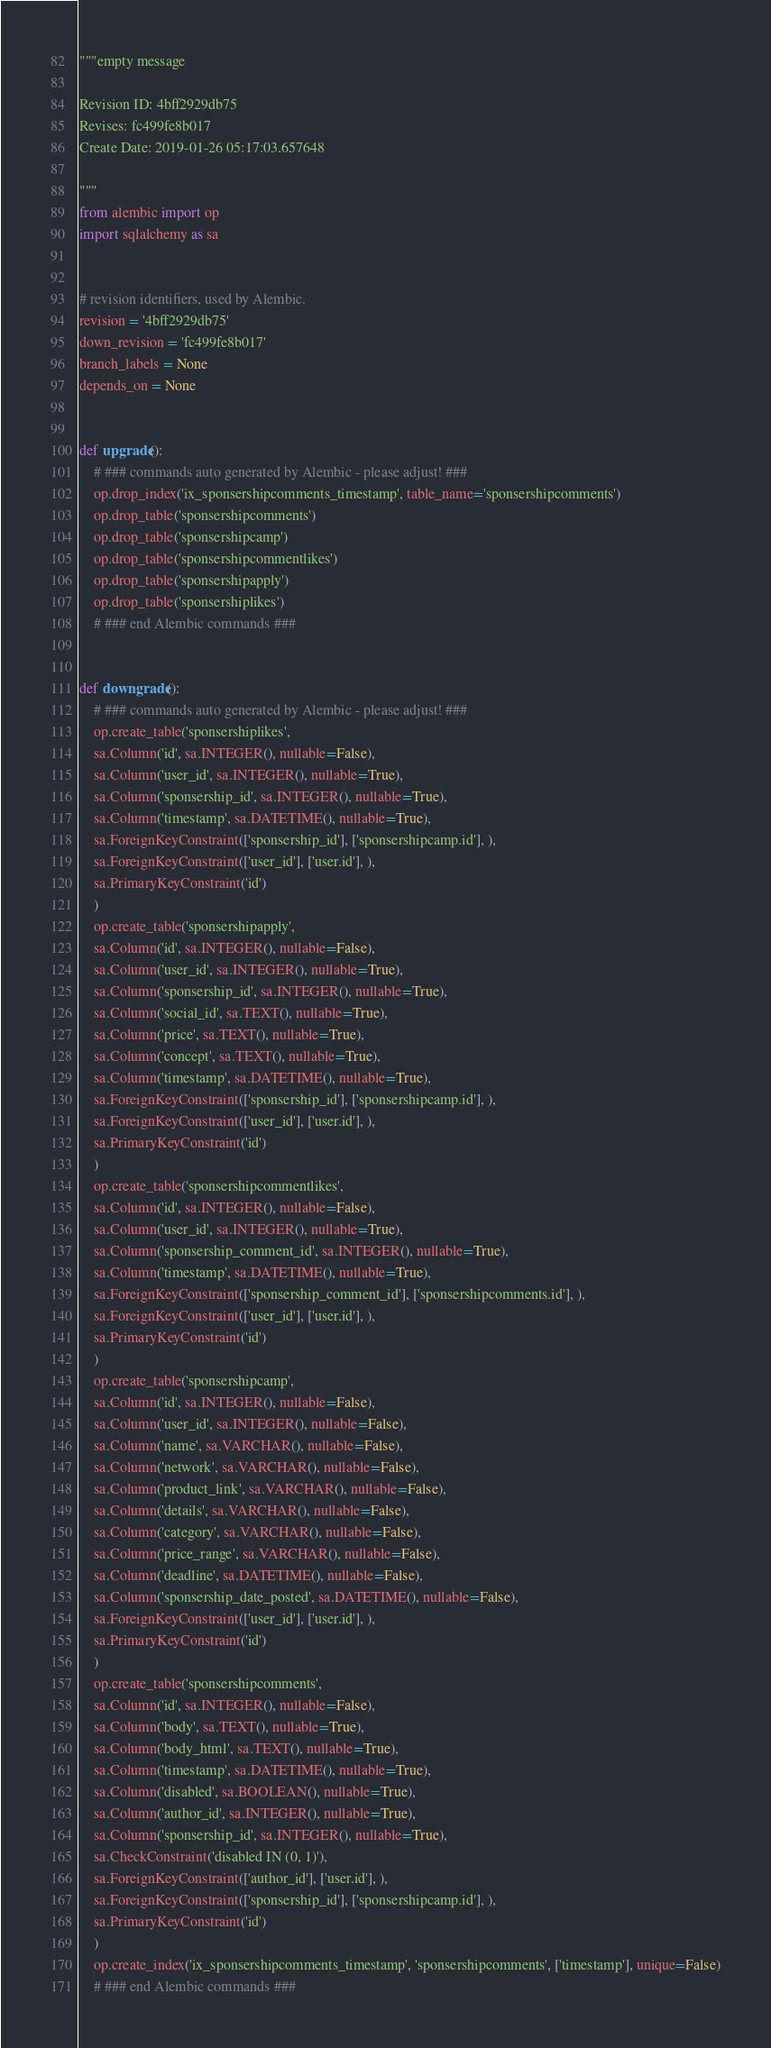Convert code to text. <code><loc_0><loc_0><loc_500><loc_500><_Python_>"""empty message

Revision ID: 4bff2929db75
Revises: fc499fe8b017
Create Date: 2019-01-26 05:17:03.657648

"""
from alembic import op
import sqlalchemy as sa


# revision identifiers, used by Alembic.
revision = '4bff2929db75'
down_revision = 'fc499fe8b017'
branch_labels = None
depends_on = None


def upgrade():
    # ### commands auto generated by Alembic - please adjust! ###
    op.drop_index('ix_sponsershipcomments_timestamp', table_name='sponsershipcomments')
    op.drop_table('sponsershipcomments')
    op.drop_table('sponsershipcamp')
    op.drop_table('sponsershipcommentlikes')
    op.drop_table('sponsershipapply')
    op.drop_table('sponsershiplikes')
    # ### end Alembic commands ###


def downgrade():
    # ### commands auto generated by Alembic - please adjust! ###
    op.create_table('sponsershiplikes',
    sa.Column('id', sa.INTEGER(), nullable=False),
    sa.Column('user_id', sa.INTEGER(), nullable=True),
    sa.Column('sponsership_id', sa.INTEGER(), nullable=True),
    sa.Column('timestamp', sa.DATETIME(), nullable=True),
    sa.ForeignKeyConstraint(['sponsership_id'], ['sponsershipcamp.id'], ),
    sa.ForeignKeyConstraint(['user_id'], ['user.id'], ),
    sa.PrimaryKeyConstraint('id')
    )
    op.create_table('sponsershipapply',
    sa.Column('id', sa.INTEGER(), nullable=False),
    sa.Column('user_id', sa.INTEGER(), nullable=True),
    sa.Column('sponsership_id', sa.INTEGER(), nullable=True),
    sa.Column('social_id', sa.TEXT(), nullable=True),
    sa.Column('price', sa.TEXT(), nullable=True),
    sa.Column('concept', sa.TEXT(), nullable=True),
    sa.Column('timestamp', sa.DATETIME(), nullable=True),
    sa.ForeignKeyConstraint(['sponsership_id'], ['sponsershipcamp.id'], ),
    sa.ForeignKeyConstraint(['user_id'], ['user.id'], ),
    sa.PrimaryKeyConstraint('id')
    )
    op.create_table('sponsershipcommentlikes',
    sa.Column('id', sa.INTEGER(), nullable=False),
    sa.Column('user_id', sa.INTEGER(), nullable=True),
    sa.Column('sponsership_comment_id', sa.INTEGER(), nullable=True),
    sa.Column('timestamp', sa.DATETIME(), nullable=True),
    sa.ForeignKeyConstraint(['sponsership_comment_id'], ['sponsershipcomments.id'], ),
    sa.ForeignKeyConstraint(['user_id'], ['user.id'], ),
    sa.PrimaryKeyConstraint('id')
    )
    op.create_table('sponsershipcamp',
    sa.Column('id', sa.INTEGER(), nullable=False),
    sa.Column('user_id', sa.INTEGER(), nullable=False),
    sa.Column('name', sa.VARCHAR(), nullable=False),
    sa.Column('network', sa.VARCHAR(), nullable=False),
    sa.Column('product_link', sa.VARCHAR(), nullable=False),
    sa.Column('details', sa.VARCHAR(), nullable=False),
    sa.Column('category', sa.VARCHAR(), nullable=False),
    sa.Column('price_range', sa.VARCHAR(), nullable=False),
    sa.Column('deadline', sa.DATETIME(), nullable=False),
    sa.Column('sponsership_date_posted', sa.DATETIME(), nullable=False),
    sa.ForeignKeyConstraint(['user_id'], ['user.id'], ),
    sa.PrimaryKeyConstraint('id')
    )
    op.create_table('sponsershipcomments',
    sa.Column('id', sa.INTEGER(), nullable=False),
    sa.Column('body', sa.TEXT(), nullable=True),
    sa.Column('body_html', sa.TEXT(), nullable=True),
    sa.Column('timestamp', sa.DATETIME(), nullable=True),
    sa.Column('disabled', sa.BOOLEAN(), nullable=True),
    sa.Column('author_id', sa.INTEGER(), nullable=True),
    sa.Column('sponsership_id', sa.INTEGER(), nullable=True),
    sa.CheckConstraint('disabled IN (0, 1)'),
    sa.ForeignKeyConstraint(['author_id'], ['user.id'], ),
    sa.ForeignKeyConstraint(['sponsership_id'], ['sponsershipcamp.id'], ),
    sa.PrimaryKeyConstraint('id')
    )
    op.create_index('ix_sponsershipcomments_timestamp', 'sponsershipcomments', ['timestamp'], unique=False)
    # ### end Alembic commands ###
</code> 